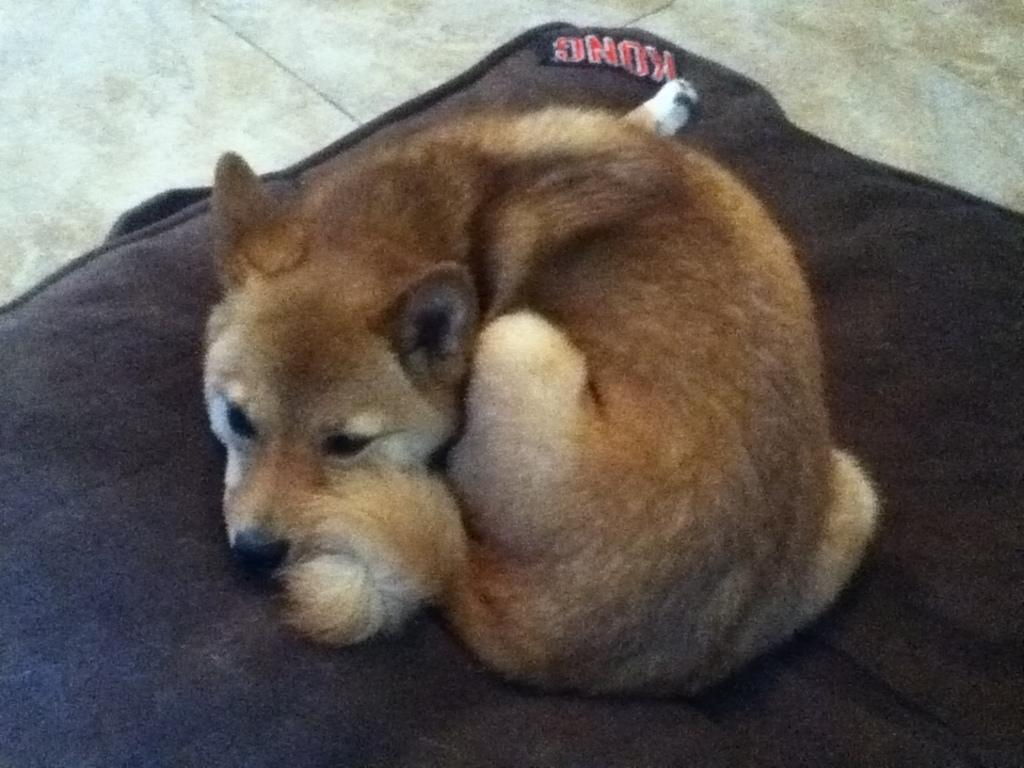What animal is present in the image? There is a dog in the image. What is the dog positioned on? The dog is on a black color cloth. Where is the dog located in the image? The dog is in the middle of the image. What can be seen in the background of the image? There is a floor visible in the background of the image. What type of twig is the dog holding in its mouth in the image? There is no twig present in the image; the dog is not holding anything in its mouth. 